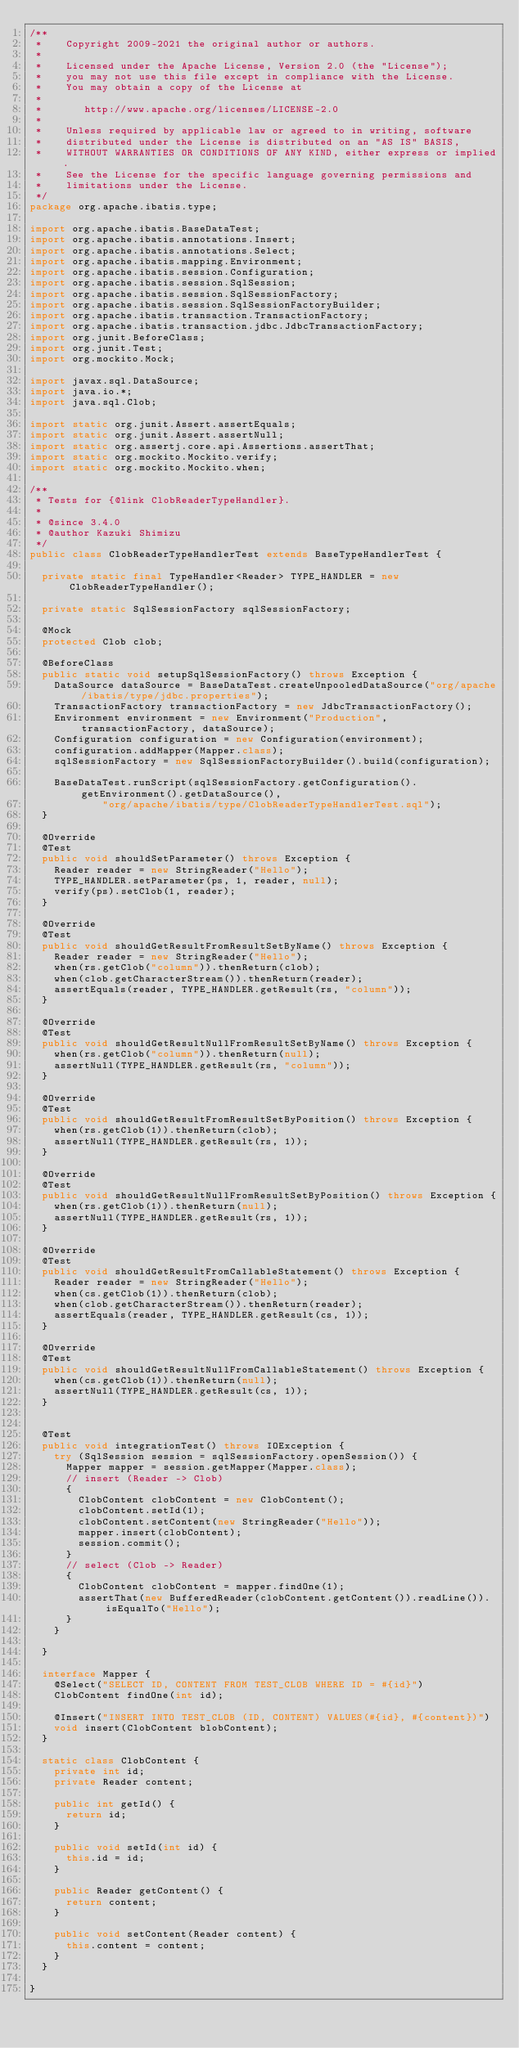Convert code to text. <code><loc_0><loc_0><loc_500><loc_500><_Java_>/**
 *    Copyright 2009-2021 the original author or authors.
 *
 *    Licensed under the Apache License, Version 2.0 (the "License");
 *    you may not use this file except in compliance with the License.
 *    You may obtain a copy of the License at
 *
 *       http://www.apache.org/licenses/LICENSE-2.0
 *
 *    Unless required by applicable law or agreed to in writing, software
 *    distributed under the License is distributed on an "AS IS" BASIS,
 *    WITHOUT WARRANTIES OR CONDITIONS OF ANY KIND, either express or implied.
 *    See the License for the specific language governing permissions and
 *    limitations under the License.
 */
package org.apache.ibatis.type;

import org.apache.ibatis.BaseDataTest;
import org.apache.ibatis.annotations.Insert;
import org.apache.ibatis.annotations.Select;
import org.apache.ibatis.mapping.Environment;
import org.apache.ibatis.session.Configuration;
import org.apache.ibatis.session.SqlSession;
import org.apache.ibatis.session.SqlSessionFactory;
import org.apache.ibatis.session.SqlSessionFactoryBuilder;
import org.apache.ibatis.transaction.TransactionFactory;
import org.apache.ibatis.transaction.jdbc.JdbcTransactionFactory;
import org.junit.BeforeClass;
import org.junit.Test;
import org.mockito.Mock;

import javax.sql.DataSource;
import java.io.*;
import java.sql.Clob;

import static org.junit.Assert.assertEquals;
import static org.junit.Assert.assertNull;
import static org.assertj.core.api.Assertions.assertThat;
import static org.mockito.Mockito.verify;
import static org.mockito.Mockito.when;

/**
 * Tests for {@link ClobReaderTypeHandler}.
 *
 * @since 3.4.0
 * @author Kazuki Shimizu
 */
public class ClobReaderTypeHandlerTest extends BaseTypeHandlerTest {

  private static final TypeHandler<Reader> TYPE_HANDLER = new ClobReaderTypeHandler();

  private static SqlSessionFactory sqlSessionFactory;

  @Mock
  protected Clob clob;

  @BeforeClass
  public static void setupSqlSessionFactory() throws Exception {
    DataSource dataSource = BaseDataTest.createUnpooledDataSource("org/apache/ibatis/type/jdbc.properties");
    TransactionFactory transactionFactory = new JdbcTransactionFactory();
    Environment environment = new Environment("Production", transactionFactory, dataSource);
    Configuration configuration = new Configuration(environment);
    configuration.addMapper(Mapper.class);
    sqlSessionFactory = new SqlSessionFactoryBuilder().build(configuration);

    BaseDataTest.runScript(sqlSessionFactory.getConfiguration().getEnvironment().getDataSource(),
            "org/apache/ibatis/type/ClobReaderTypeHandlerTest.sql");
  }

  @Override
  @Test
  public void shouldSetParameter() throws Exception {
    Reader reader = new StringReader("Hello");
    TYPE_HANDLER.setParameter(ps, 1, reader, null);
    verify(ps).setClob(1, reader);
  }

  @Override
  @Test
  public void shouldGetResultFromResultSetByName() throws Exception {
    Reader reader = new StringReader("Hello");
    when(rs.getClob("column")).thenReturn(clob);
    when(clob.getCharacterStream()).thenReturn(reader);
    assertEquals(reader, TYPE_HANDLER.getResult(rs, "column"));
  }

  @Override
  @Test
  public void shouldGetResultNullFromResultSetByName() throws Exception {
    when(rs.getClob("column")).thenReturn(null);
    assertNull(TYPE_HANDLER.getResult(rs, "column"));
  }

  @Override
  @Test
  public void shouldGetResultFromResultSetByPosition() throws Exception {
    when(rs.getClob(1)).thenReturn(clob);
    assertNull(TYPE_HANDLER.getResult(rs, 1));
  }

  @Override
  @Test
  public void shouldGetResultNullFromResultSetByPosition() throws Exception {
    when(rs.getClob(1)).thenReturn(null);
    assertNull(TYPE_HANDLER.getResult(rs, 1));
  }

  @Override
  @Test
  public void shouldGetResultFromCallableStatement() throws Exception {
    Reader reader = new StringReader("Hello");
    when(cs.getClob(1)).thenReturn(clob);
    when(clob.getCharacterStream()).thenReturn(reader);
    assertEquals(reader, TYPE_HANDLER.getResult(cs, 1));
  }

  @Override
  @Test
  public void shouldGetResultNullFromCallableStatement() throws Exception {
    when(cs.getClob(1)).thenReturn(null);
    assertNull(TYPE_HANDLER.getResult(cs, 1));
  }


  @Test
  public void integrationTest() throws IOException {
    try (SqlSession session = sqlSessionFactory.openSession()) {
      Mapper mapper = session.getMapper(Mapper.class);
      // insert (Reader -> Clob)
      {
        ClobContent clobContent = new ClobContent();
        clobContent.setId(1);
        clobContent.setContent(new StringReader("Hello"));
        mapper.insert(clobContent);
        session.commit();
      }
      // select (Clob -> Reader)
      {
        ClobContent clobContent = mapper.findOne(1);
        assertThat(new BufferedReader(clobContent.getContent()).readLine()).isEqualTo("Hello");
      }
    }

  }

  interface Mapper {
    @Select("SELECT ID, CONTENT FROM TEST_CLOB WHERE ID = #{id}")
    ClobContent findOne(int id);

    @Insert("INSERT INTO TEST_CLOB (ID, CONTENT) VALUES(#{id}, #{content})")
    void insert(ClobContent blobContent);
  }

  static class ClobContent {
    private int id;
    private Reader content;

    public int getId() {
      return id;
    }

    public void setId(int id) {
      this.id = id;
    }

    public Reader getContent() {
      return content;
    }

    public void setContent(Reader content) {
      this.content = content;
    }
  }

}</code> 